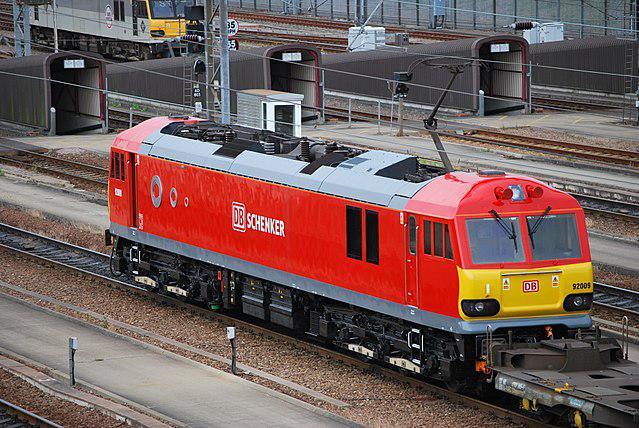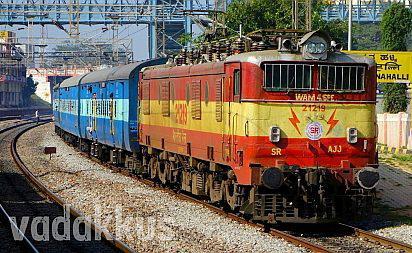The first image is the image on the left, the second image is the image on the right. Examine the images to the left and right. Is the description "People are standing by a railing next to a train in one image." accurate? Answer yes or no. No. The first image is the image on the left, the second image is the image on the right. Given the left and right images, does the statement "A train locomotive in each image is a distinct style and color, and positioned at a different angle than that of the other image." hold true? Answer yes or no. No. 